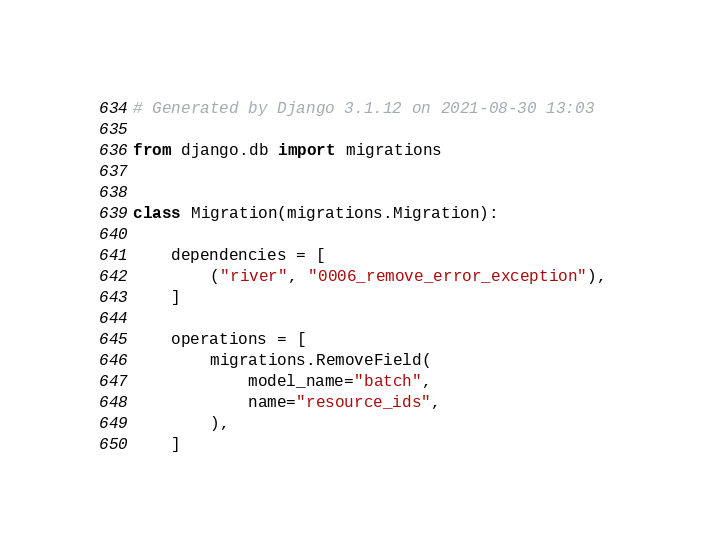<code> <loc_0><loc_0><loc_500><loc_500><_Python_># Generated by Django 3.1.12 on 2021-08-30 13:03

from django.db import migrations


class Migration(migrations.Migration):

    dependencies = [
        ("river", "0006_remove_error_exception"),
    ]

    operations = [
        migrations.RemoveField(
            model_name="batch",
            name="resource_ids",
        ),
    ]
</code> 